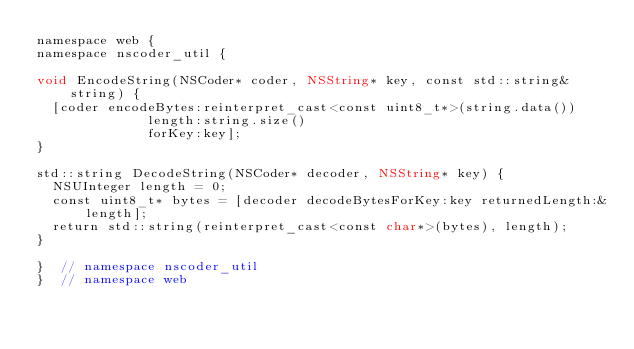<code> <loc_0><loc_0><loc_500><loc_500><_ObjectiveC_>namespace web {
namespace nscoder_util {

void EncodeString(NSCoder* coder, NSString* key, const std::string& string) {
  [coder encodeBytes:reinterpret_cast<const uint8_t*>(string.data())
              length:string.size()
              forKey:key];
}

std::string DecodeString(NSCoder* decoder, NSString* key) {
  NSUInteger length = 0;
  const uint8_t* bytes = [decoder decodeBytesForKey:key returnedLength:&length];
  return std::string(reinterpret_cast<const char*>(bytes), length);
}

}  // namespace nscoder_util
}  // namespace web
</code> 